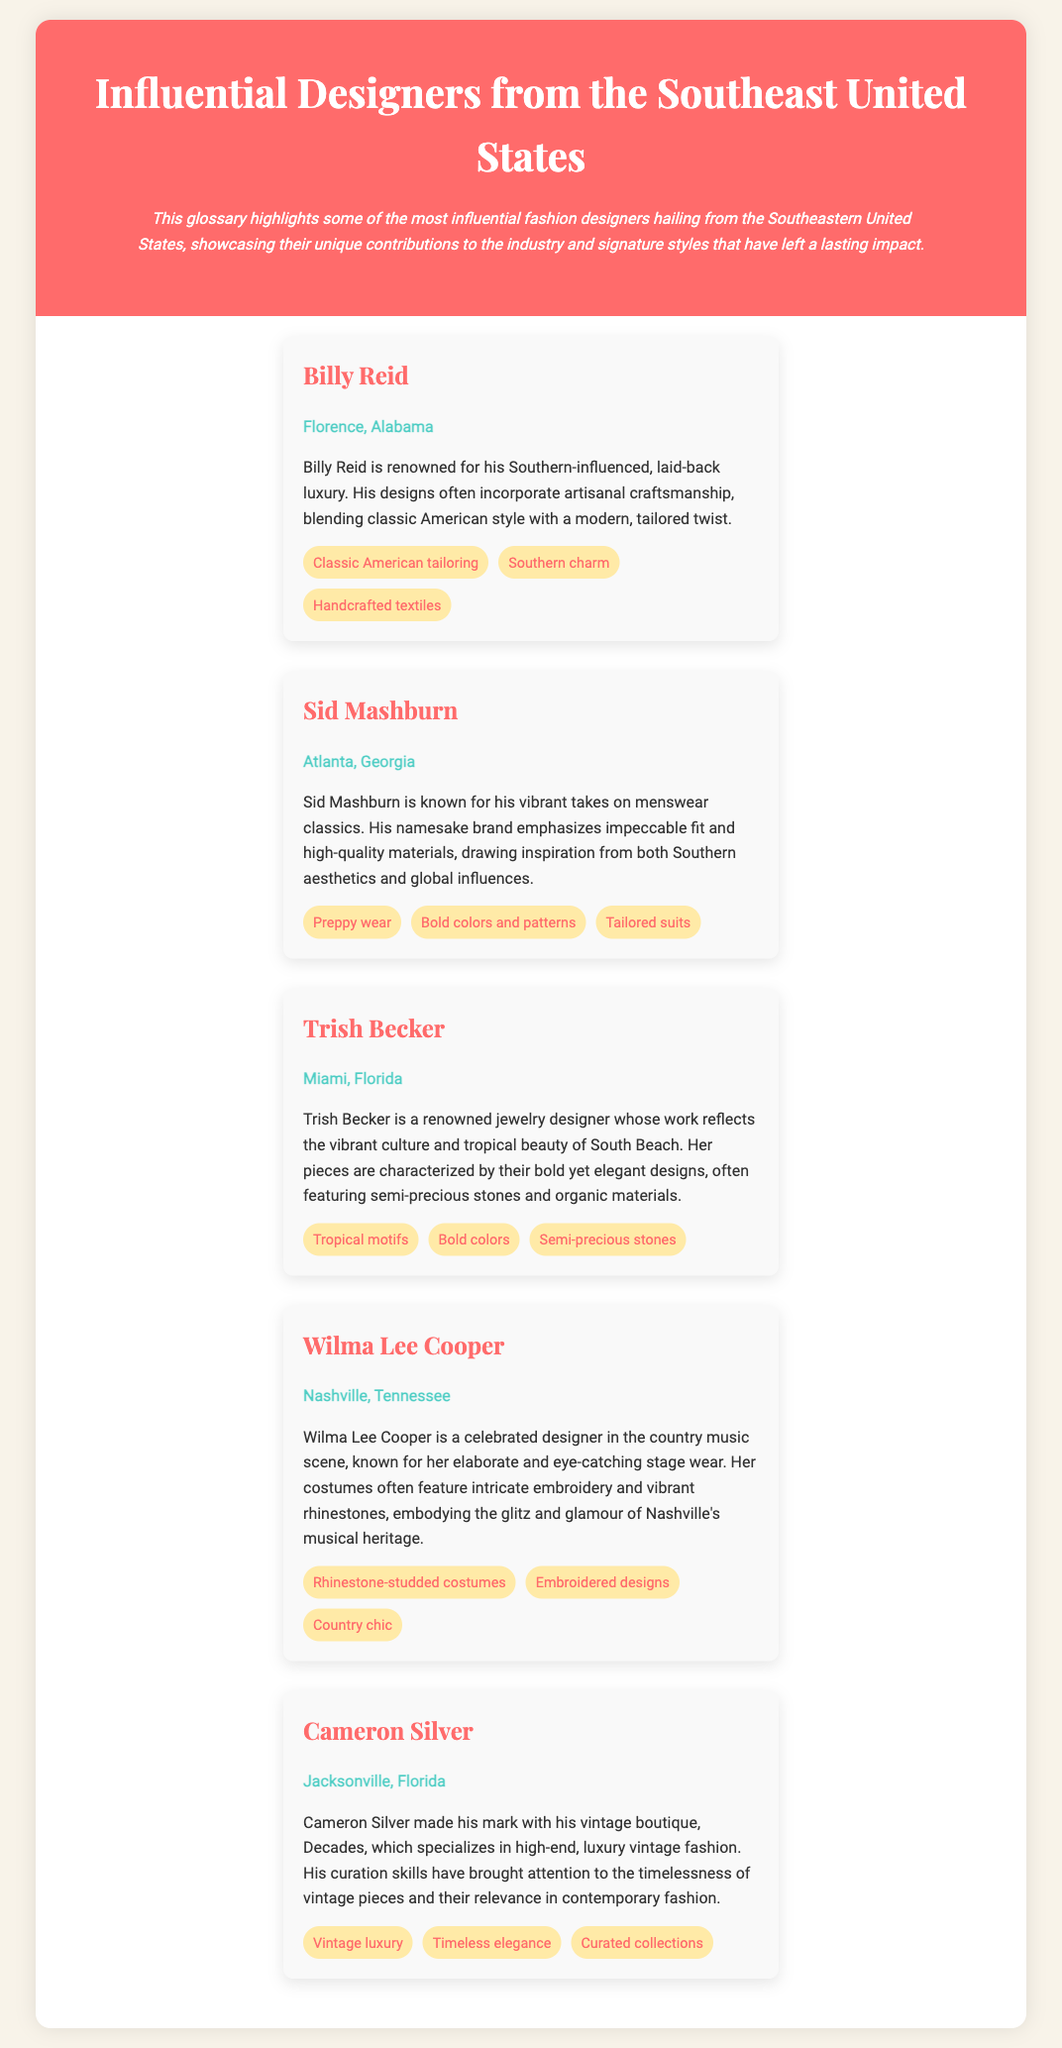What is the name of the designer from Florence, Alabama? The document provides profiles of various designers, including their origins, and indicates that Billy Reid is from Florence, Alabama.
Answer: Billy Reid What city is Sid Mashburn associated with? The document lists Sid Mashburn as being from Atlanta, Georgia, providing a clear location for each designer.
Answer: Atlanta, Georgia Which designer is known for their work with jewelry? The profile of Trish Becker indicates that she specializes in jewelry design.
Answer: Trish Becker What style is associated with Wilma Lee Cooper's designs? The document notes that Wilma Lee Cooper is recognized for rhinestone-studded costumes, highlighting a specific aspect of her signature style.
Answer: Rhinestone-studded costumes How many designers are featured in this glossary? A count of the designer profiles presented in the document shows that there are five designers highlighted.
Answer: Five Which designer emphasizes vintage luxury? The profile of Cameron Silver discusses his focus on vintage luxury fashion, indicating his niche within the industry.
Answer: Cameron Silver What is a signature style of Sid Mashburn? The document states that Sid Mashburn is known for bold colors and patterns in his menswear collections, identifying a key aspect of his design approach.
Answer: Bold colors and patterns What influence is Billy Reid known for in his designs? The document mentions that Billy Reid’s work is influenced by Southern charm, summarizing the essence of his design ethos.
Answer: Southern charm 